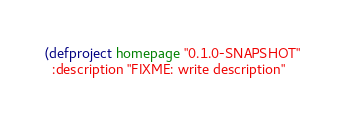<code> <loc_0><loc_0><loc_500><loc_500><_Clojure_>(defproject homepage "0.1.0-SNAPSHOT"
  :description "FIXME: write description"</code> 